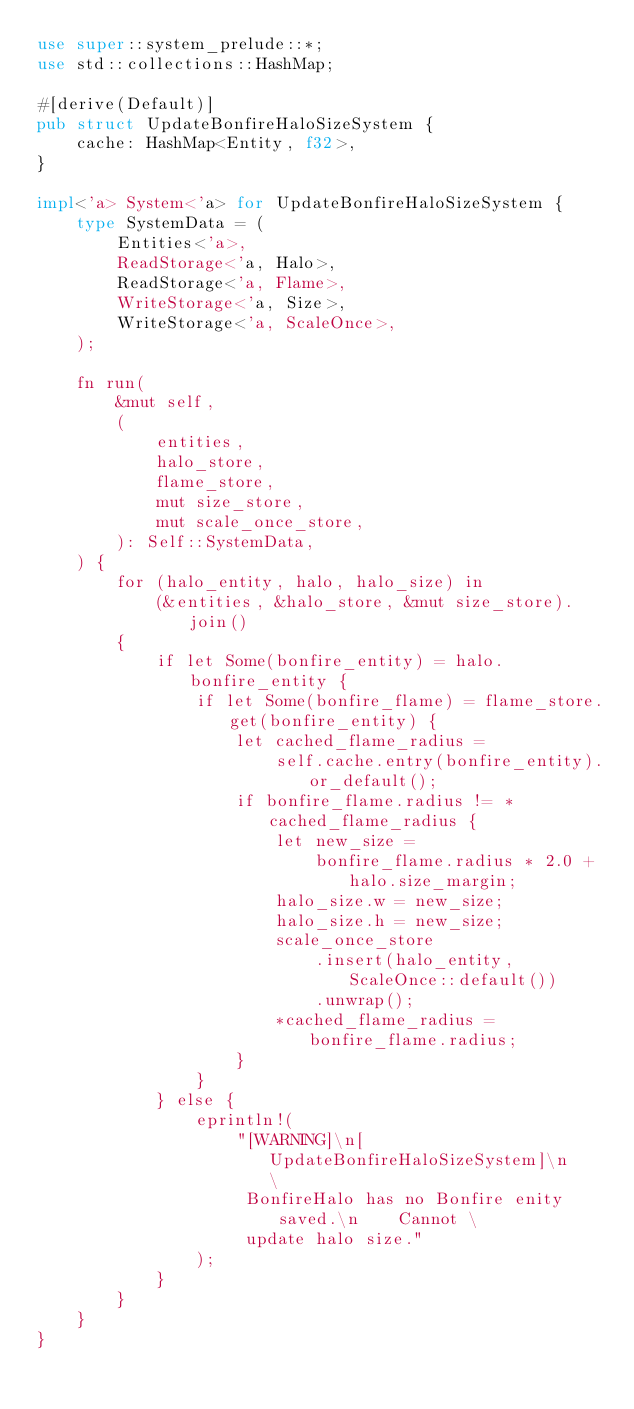<code> <loc_0><loc_0><loc_500><loc_500><_Rust_>use super::system_prelude::*;
use std::collections::HashMap;

#[derive(Default)]
pub struct UpdateBonfireHaloSizeSystem {
    cache: HashMap<Entity, f32>,
}

impl<'a> System<'a> for UpdateBonfireHaloSizeSystem {
    type SystemData = (
        Entities<'a>,
        ReadStorage<'a, Halo>,
        ReadStorage<'a, Flame>,
        WriteStorage<'a, Size>,
        WriteStorage<'a, ScaleOnce>,
    );

    fn run(
        &mut self,
        (
            entities,
            halo_store,
            flame_store,
            mut size_store,
            mut scale_once_store,
        ): Self::SystemData,
    ) {
        for (halo_entity, halo, halo_size) in
            (&entities, &halo_store, &mut size_store).join()
        {
            if let Some(bonfire_entity) = halo.bonfire_entity {
                if let Some(bonfire_flame) = flame_store.get(bonfire_entity) {
                    let cached_flame_radius =
                        self.cache.entry(bonfire_entity).or_default();
                    if bonfire_flame.radius != *cached_flame_radius {
                        let new_size =
                            bonfire_flame.radius * 2.0 + halo.size_margin;
                        halo_size.w = new_size;
                        halo_size.h = new_size;
                        scale_once_store
                            .insert(halo_entity, ScaleOnce::default())
                            .unwrap();
                        *cached_flame_radius = bonfire_flame.radius;
                    }
                }
            } else {
                eprintln!(
                    "[WARNING]\n[UpdateBonfireHaloSizeSystem]\n    \
                     BonfireHalo has no Bonfire enity saved.\n    Cannot \
                     update halo size."
                );
            }
        }
    }
}
</code> 